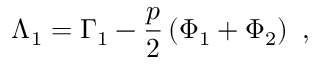Convert formula to latex. <formula><loc_0><loc_0><loc_500><loc_500>\Lambda _ { 1 } = \Gamma _ { 1 } - \frac { p } { 2 } \left ( \Phi _ { 1 } + \Phi _ { 2 } \right ) \ ,</formula> 